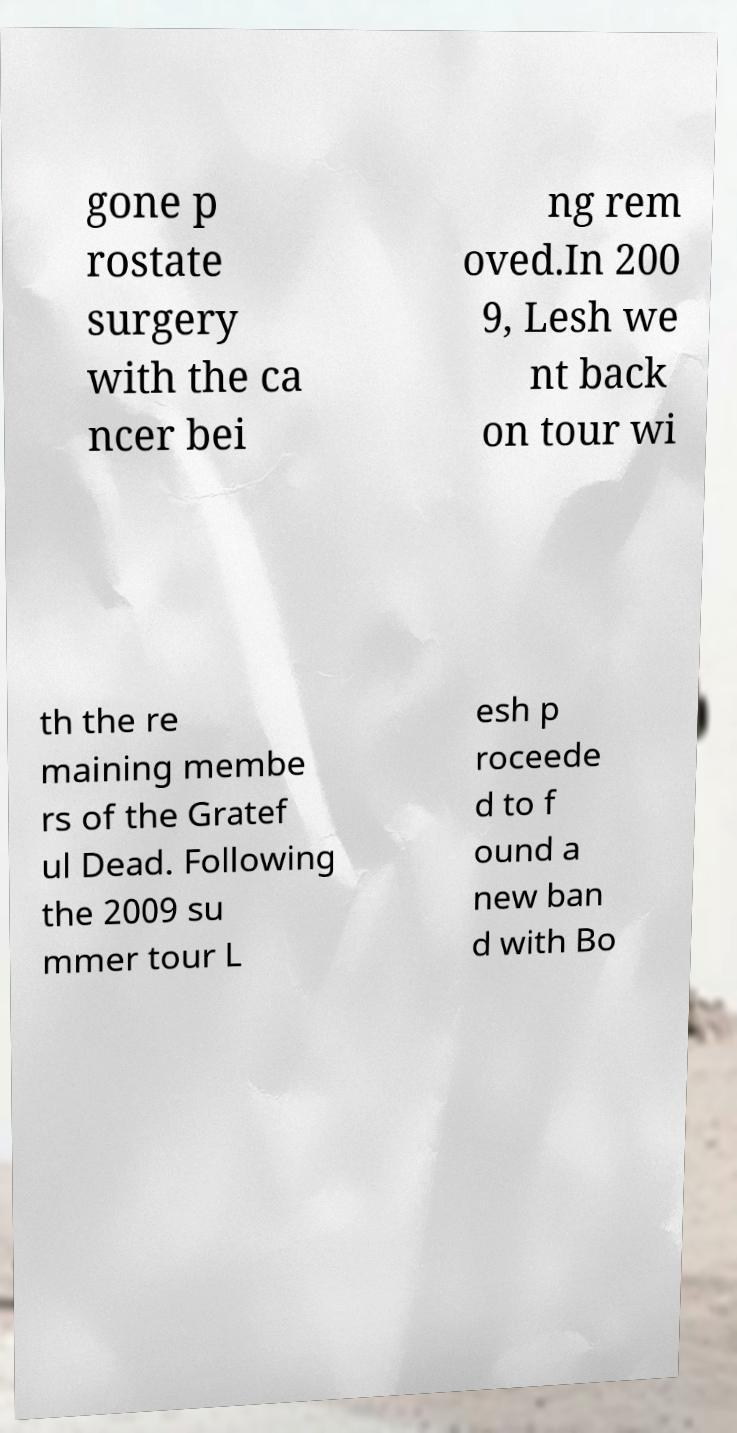Could you assist in decoding the text presented in this image and type it out clearly? gone p rostate surgery with the ca ncer bei ng rem oved.In 200 9, Lesh we nt back on tour wi th the re maining membe rs of the Gratef ul Dead. Following the 2009 su mmer tour L esh p roceede d to f ound a new ban d with Bo 